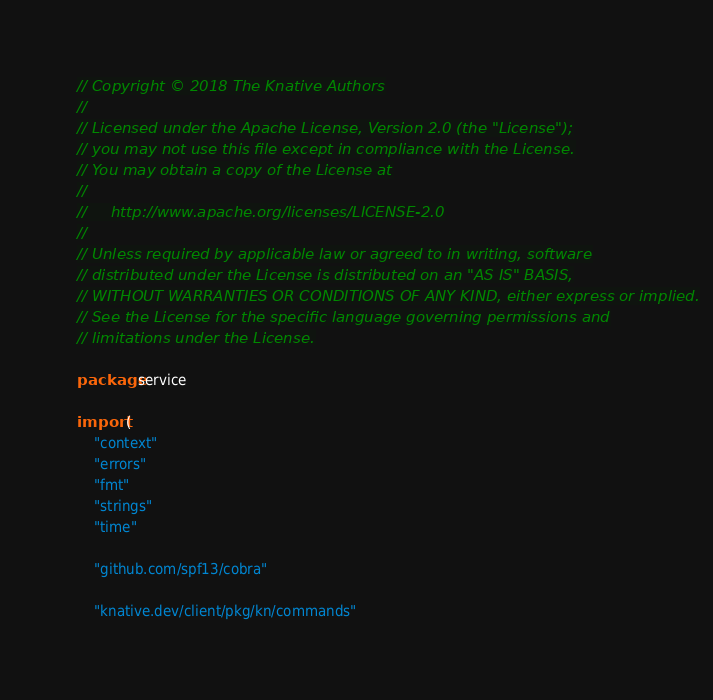<code> <loc_0><loc_0><loc_500><loc_500><_Go_>// Copyright © 2018 The Knative Authors
//
// Licensed under the Apache License, Version 2.0 (the "License");
// you may not use this file except in compliance with the License.
// You may obtain a copy of the License at
//
//     http://www.apache.org/licenses/LICENSE-2.0
//
// Unless required by applicable law or agreed to in writing, software
// distributed under the License is distributed on an "AS IS" BASIS,
// WITHOUT WARRANTIES OR CONDITIONS OF ANY KIND, either express or implied.
// See the License for the specific language governing permissions and
// limitations under the License.

package service

import (
	"context"
	"errors"
	"fmt"
	"strings"
	"time"

	"github.com/spf13/cobra"

	"knative.dev/client/pkg/kn/commands"</code> 